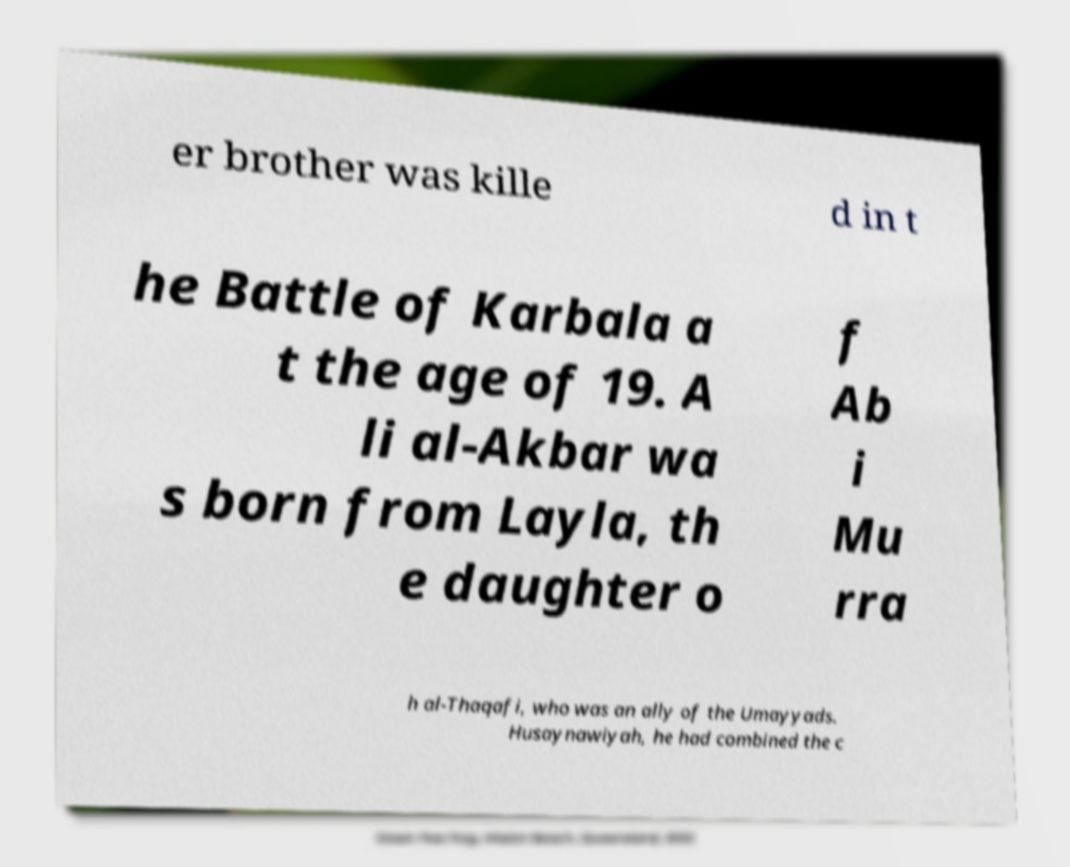What messages or text are displayed in this image? I need them in a readable, typed format. er brother was kille d in t he Battle of Karbala a t the age of 19. A li al-Akbar wa s born from Layla, th e daughter o f Ab i Mu rra h al-Thaqafi, who was an ally of the Umayyads. Husaynawiyah, he had combined the c 